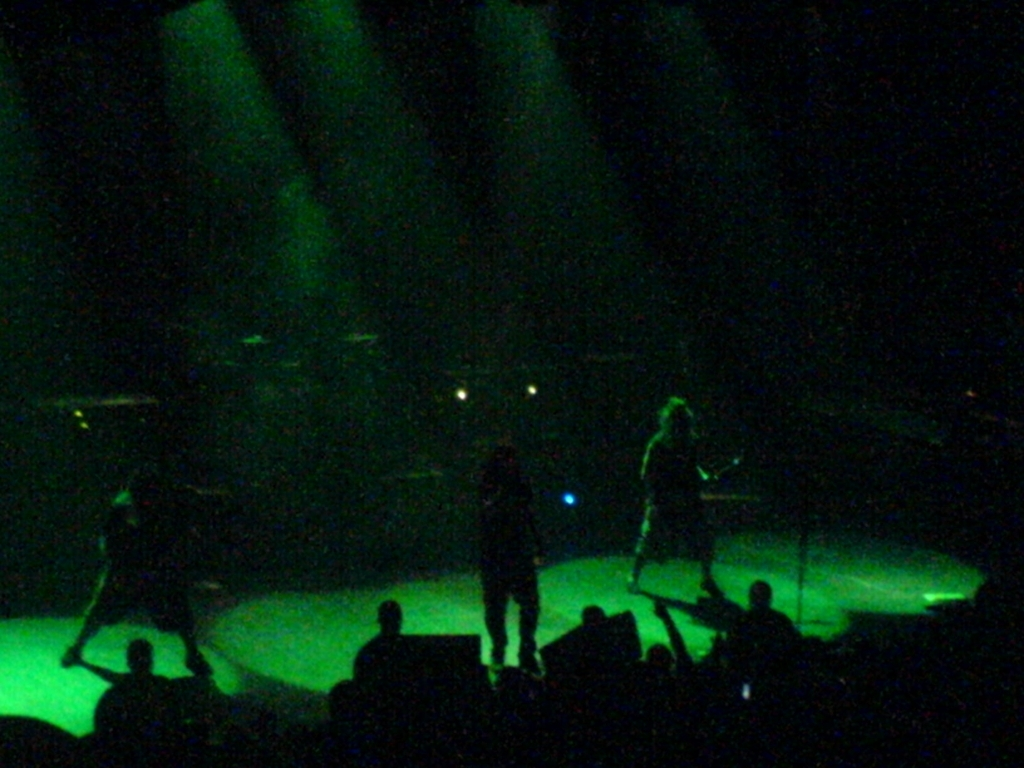Can you tell me more about the atmosphere in this image? The image conveys a vibrant concert atmosphere with dynamic lighting, suggesting an energetic and immersive experience for the audience. What emotions might the audience be feeling based on this image? Considering the event, the audience might be feeling excitement and joy, being part of a live musical performance, as such events often evoke a sense of unity and elation. 